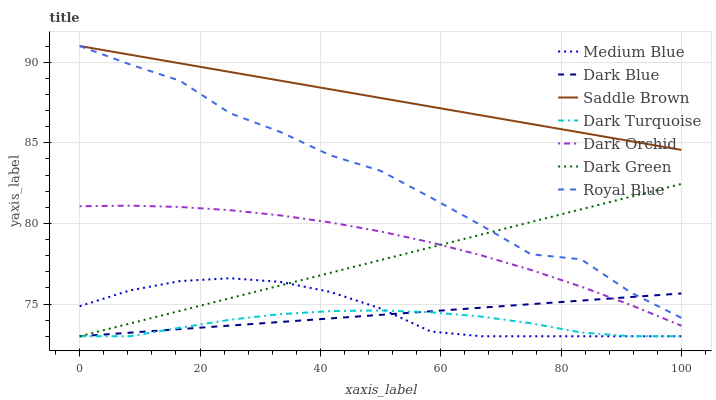Does Dark Turquoise have the minimum area under the curve?
Answer yes or no. Yes. Does Saddle Brown have the maximum area under the curve?
Answer yes or no. Yes. Does Medium Blue have the minimum area under the curve?
Answer yes or no. No. Does Medium Blue have the maximum area under the curve?
Answer yes or no. No. Is Dark Blue the smoothest?
Answer yes or no. Yes. Is Royal Blue the roughest?
Answer yes or no. Yes. Is Dark Turquoise the smoothest?
Answer yes or no. No. Is Dark Turquoise the roughest?
Answer yes or no. No. Does Dark Turquoise have the lowest value?
Answer yes or no. Yes. Does Dark Orchid have the lowest value?
Answer yes or no. No. Does Saddle Brown have the highest value?
Answer yes or no. Yes. Does Medium Blue have the highest value?
Answer yes or no. No. Is Medium Blue less than Dark Orchid?
Answer yes or no. Yes. Is Royal Blue greater than Dark Turquoise?
Answer yes or no. Yes. Does Dark Blue intersect Dark Green?
Answer yes or no. Yes. Is Dark Blue less than Dark Green?
Answer yes or no. No. Is Dark Blue greater than Dark Green?
Answer yes or no. No. Does Medium Blue intersect Dark Orchid?
Answer yes or no. No. 